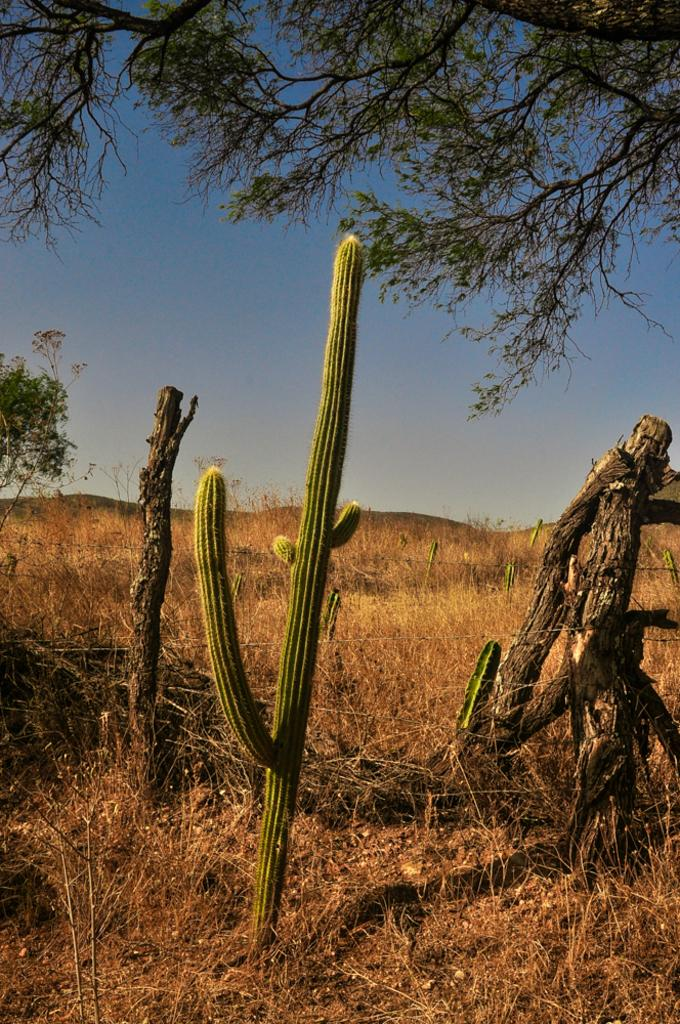What type of vegetation is present at the bottom of the image? There are plants at the bottom of the image. What type of vegetation is in the middle of the image? There is grass in the middle of the image. What type of vegetation is at the top of the image? There is a tree at the top of the image. How does the tree say good-bye to the plants in the image? Trees do not have the ability to say good-bye, as they are inanimate objects. 